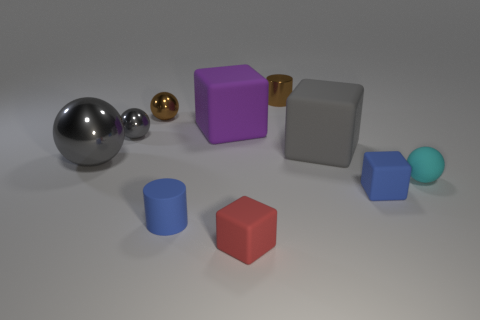Subtract 2 cubes. How many cubes are left? 2 Subtract all purple cubes. How many cubes are left? 3 Subtract all shiny spheres. How many spheres are left? 1 Subtract all green balls. Subtract all purple cubes. How many balls are left? 4 Subtract all spheres. How many objects are left? 6 Add 9 small gray metallic cylinders. How many small gray metallic cylinders exist? 9 Subtract 0 red cylinders. How many objects are left? 10 Subtract all big objects. Subtract all small gray rubber objects. How many objects are left? 7 Add 1 small cyan things. How many small cyan things are left? 2 